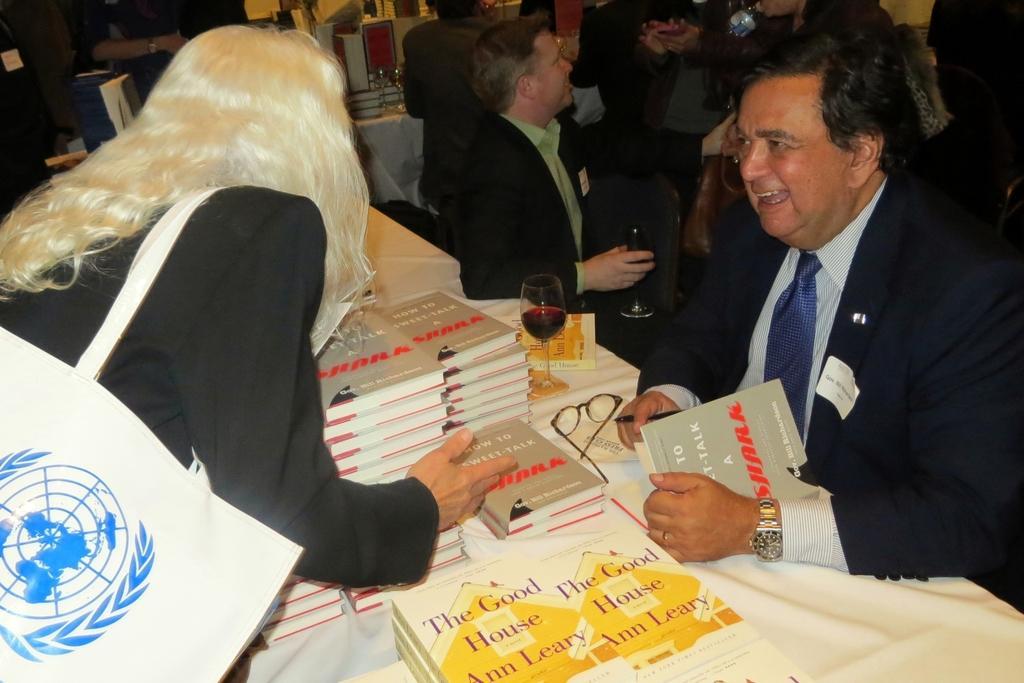Describe this image in one or two sentences. In this image we can see many people. A lady wearing a handbag on her shoulders. We can see a logo on the handbag. There are many books and few other objects placed on the tables. A person is holding a pen and a book in the image. 